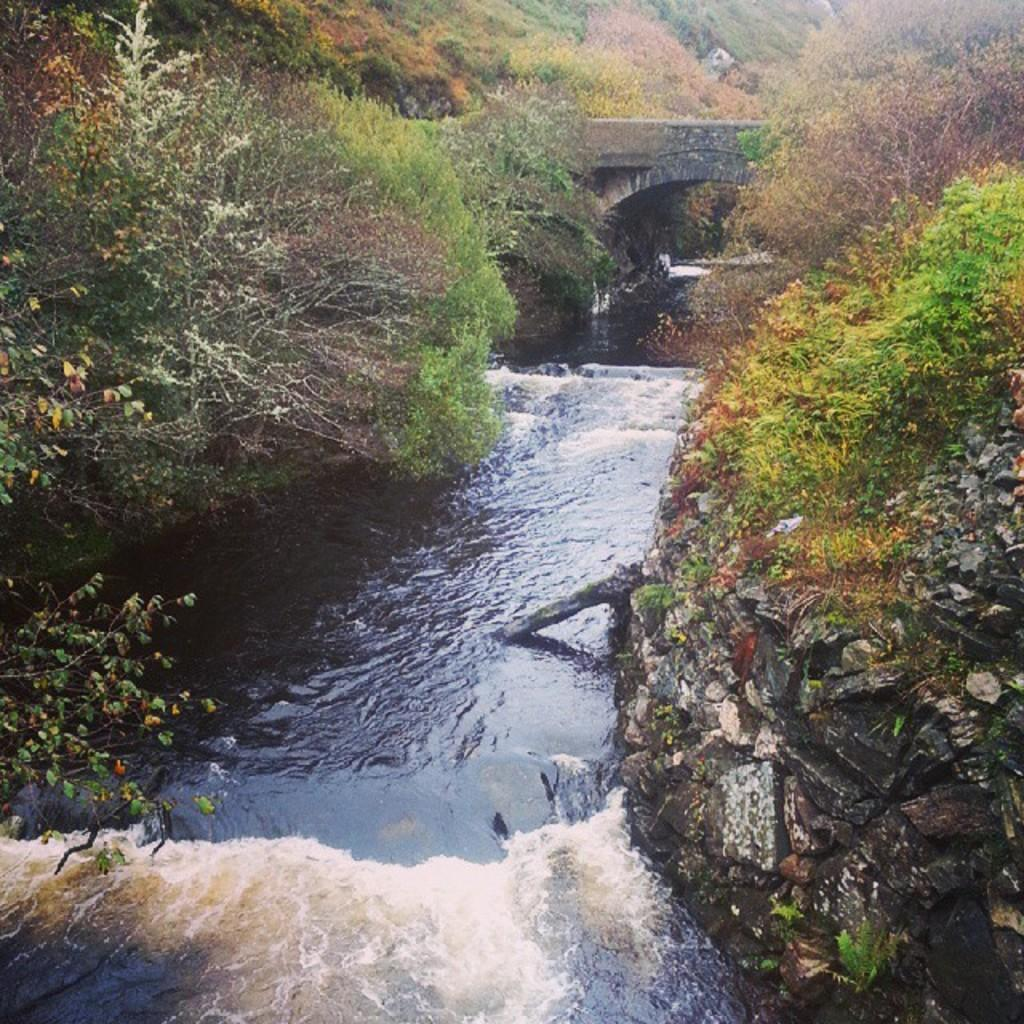What is the primary element visible in the image? There is water in the image. What can be seen near the water? There are many trees near the water. Is there any other object or structure near the water? Yes, there is a rock near the water. What can be seen in the background of the image? There is a bridge visible in the background of the image. What type of flower is the queen holding in the image? There is no queen or flower present in the image; it features water, trees, a rock, and a bridge. 